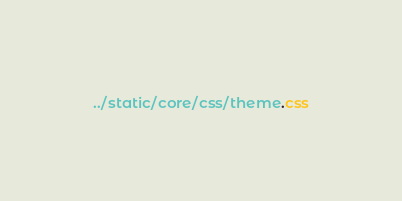<code> <loc_0><loc_0><loc_500><loc_500><_CSS_>../static/core/css/theme.css</code> 